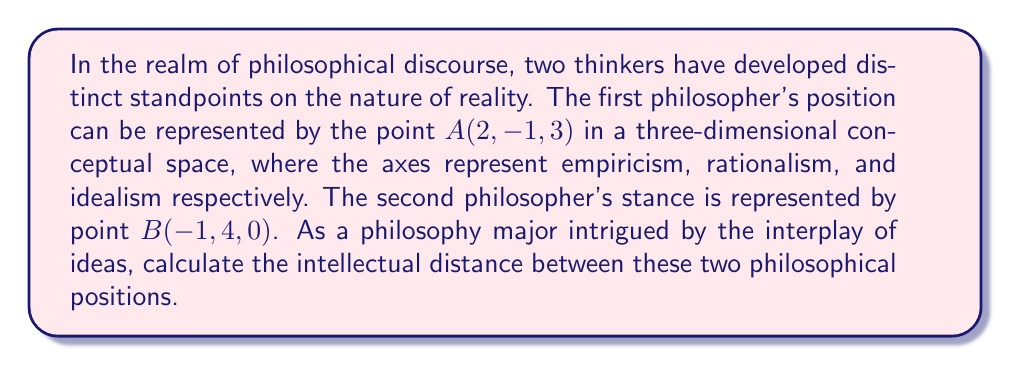Give your solution to this math problem. To solve this problem, we'll use the distance formula in three-dimensional space. The distance $d$ between two points $(x_1, y_1, z_1)$ and $(x_2, y_2, z_2)$ is given by:

$$d = \sqrt{(x_2-x_1)^2 + (y_2-y_1)^2 + (z_2-z_1)^2}$$

Let's break it down step-by-step:

1) Identify the coordinates:
   Point A: $(x_1, y_1, z_1) = (2, -1, 3)$
   Point B: $(x_2, y_2, z_2) = (-1, 4, 0)$

2) Calculate the differences:
   $x_2 - x_1 = -1 - 2 = -3$
   $y_2 - y_1 = 4 - (-1) = 5$
   $z_2 - z_1 = 0 - 3 = -3$

3) Square these differences:
   $(-3)^2 = 9$
   $5^2 = 25$
   $(-3)^2 = 9$

4) Sum the squared differences:
   $9 + 25 + 9 = 43$

5) Take the square root of the sum:
   $\sqrt{43}$

Thus, the intellectual distance between the two philosophical standpoints is $\sqrt{43}$ units in this conceptual space.
Answer: $\sqrt{43}$ 